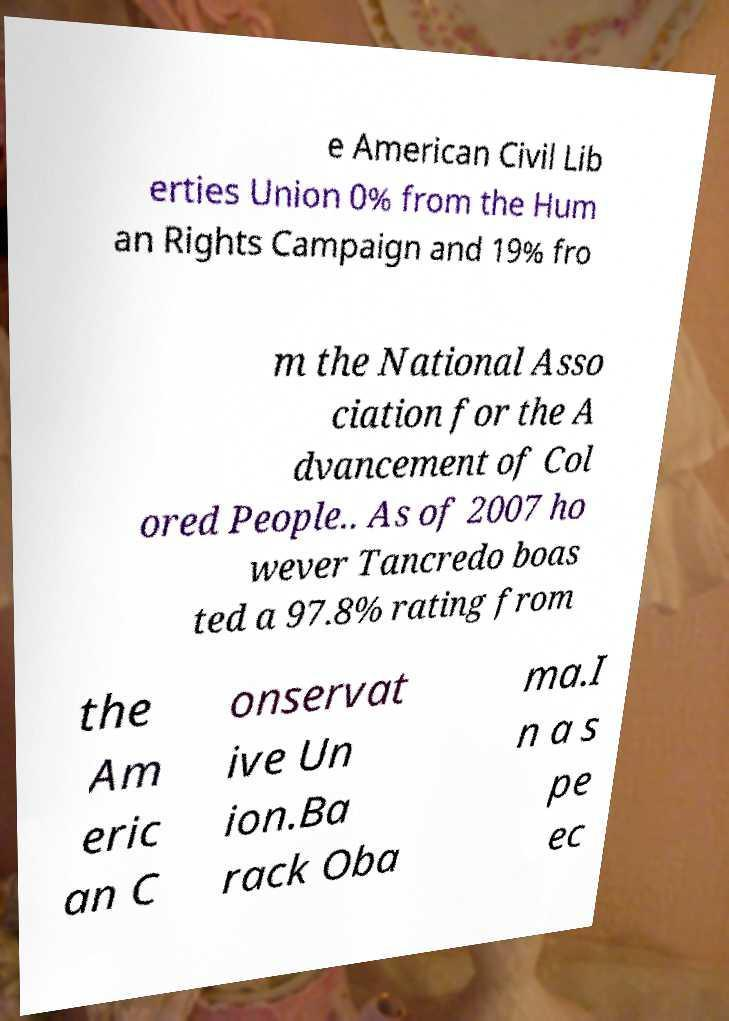There's text embedded in this image that I need extracted. Can you transcribe it verbatim? e American Civil Lib erties Union 0% from the Hum an Rights Campaign and 19% fro m the National Asso ciation for the A dvancement of Col ored People.. As of 2007 ho wever Tancredo boas ted a 97.8% rating from the Am eric an C onservat ive Un ion.Ba rack Oba ma.I n a s pe ec 